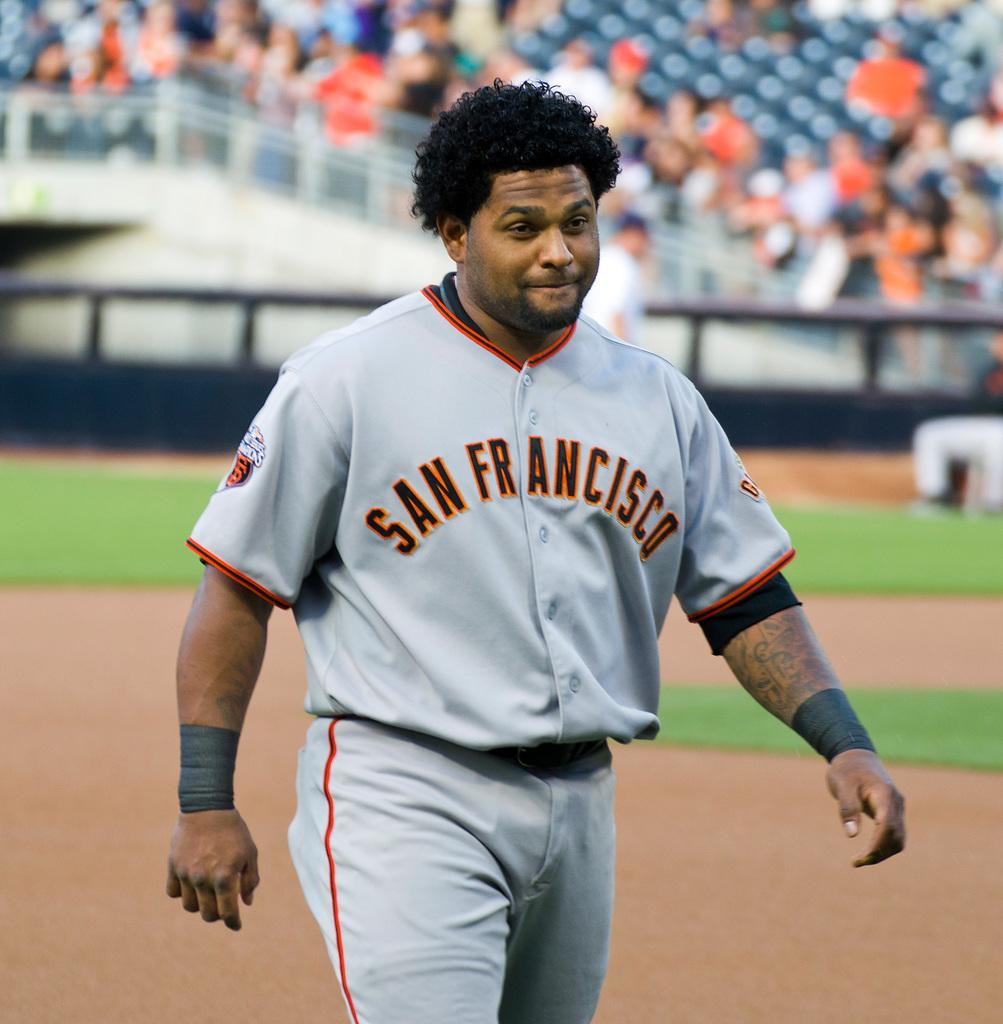What city does this player represent?
Your answer should be very brief. San francisco. What is the first word on his jersey?
Make the answer very short. San. 